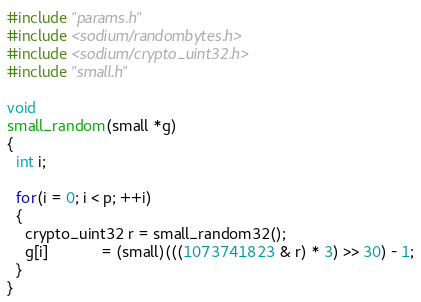Convert code to text. <code><loc_0><loc_0><loc_500><loc_500><_C_>#include "params.h"
#include <sodium/randombytes.h>
#include <sodium/crypto_uint32.h>
#include "small.h"

void
small_random(small *g)
{
  int i;

  for(i = 0; i < p; ++i)
  {
    crypto_uint32 r = small_random32();
    g[i]            = (small)(((1073741823 & r) * 3) >> 30) - 1;
  }
}
</code> 